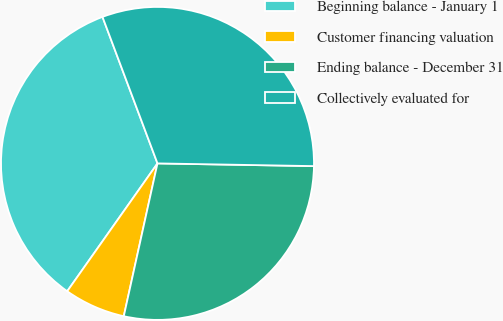Convert chart to OTSL. <chart><loc_0><loc_0><loc_500><loc_500><pie_chart><fcel>Beginning balance - January 1<fcel>Customer financing valuation<fcel>Ending balance - December 31<fcel>Collectively evaluated for<nl><fcel>34.5%<fcel>6.33%<fcel>28.18%<fcel>30.99%<nl></chart> 